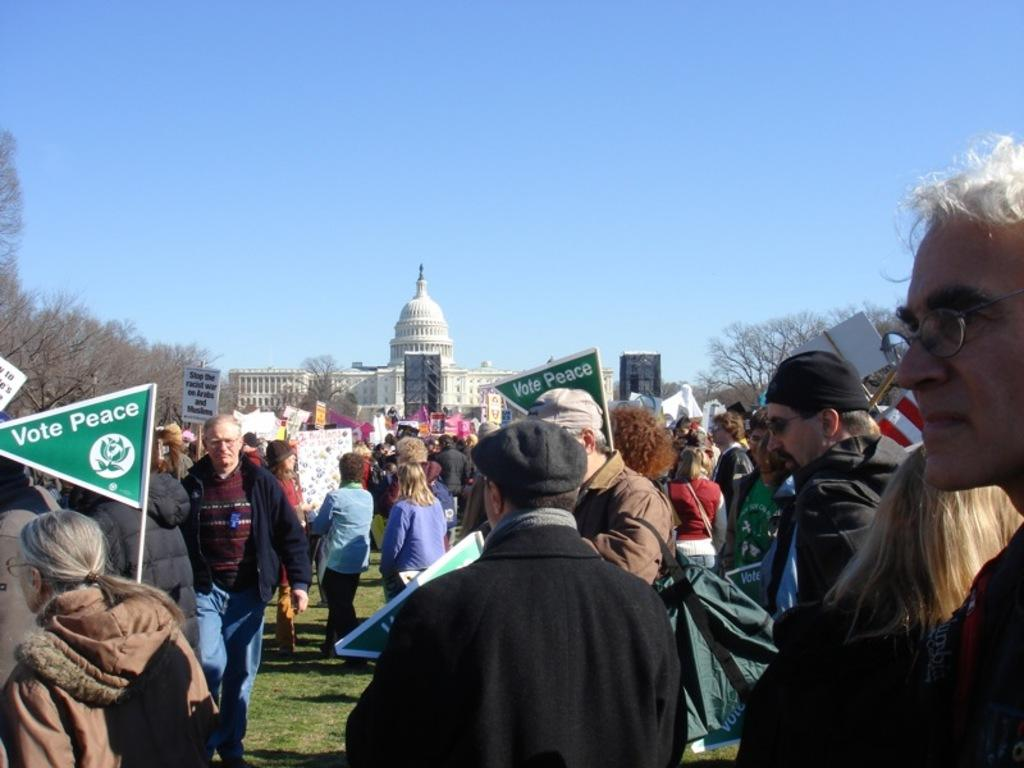What are the people in the image doing? The people in the image are standing and holding posters. What can be seen in the background of the image? There is a building and trees in the image. What is visible at the top of the image? The sky is visible at the top of the image. How many chairs are visible in the image? There are no chairs visible in the image. What type of spark can be seen coming from the building in the image? There is no spark present in the image; the building is not depicted as having any spark. 